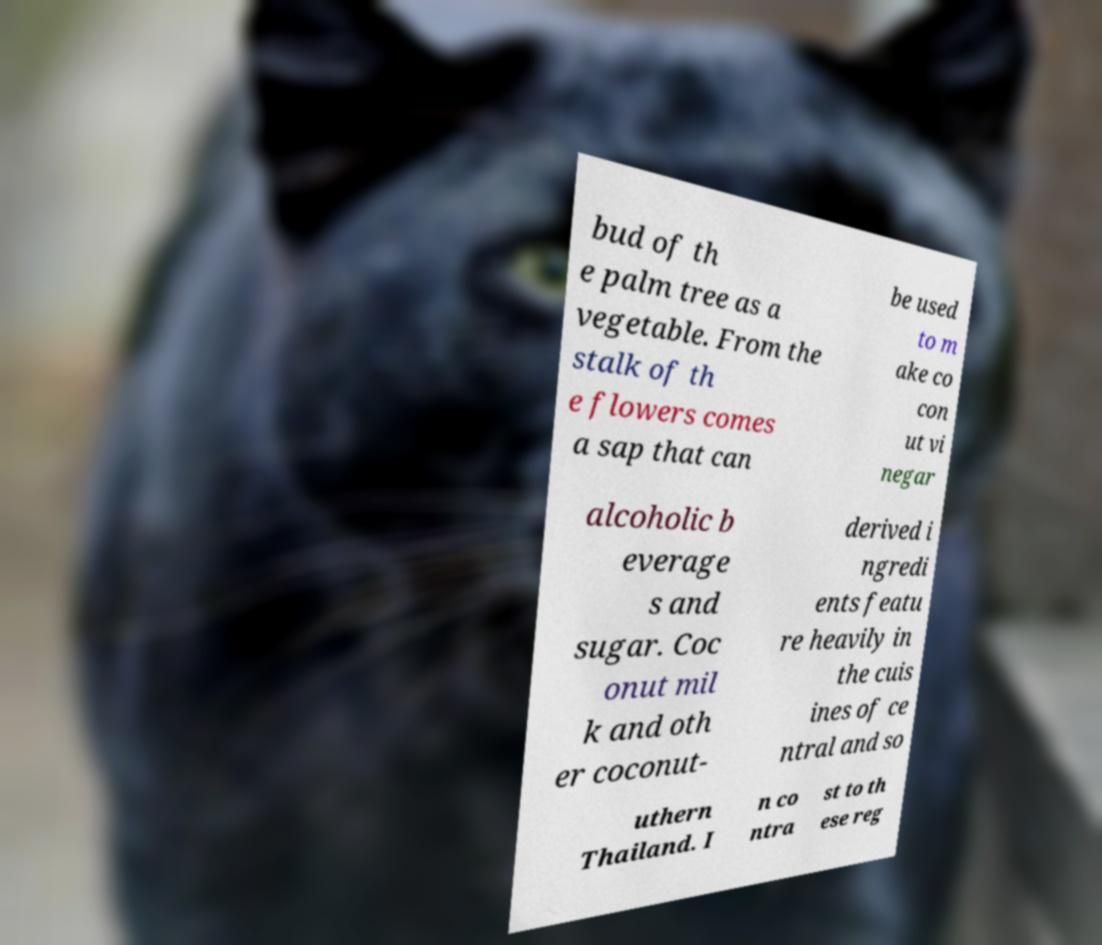For documentation purposes, I need the text within this image transcribed. Could you provide that? bud of th e palm tree as a vegetable. From the stalk of th e flowers comes a sap that can be used to m ake co con ut vi negar alcoholic b everage s and sugar. Coc onut mil k and oth er coconut- derived i ngredi ents featu re heavily in the cuis ines of ce ntral and so uthern Thailand. I n co ntra st to th ese reg 